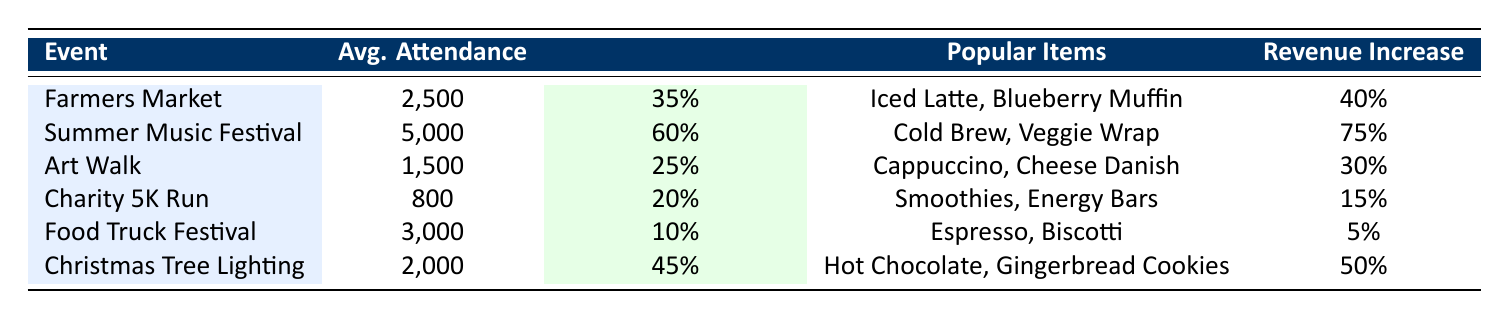What's the average attendance for the Summer Music Festival? The attendance for the Summer Music Festival is listed directly in the table as 5,000, which is a straightforward retrieval from the data.
Answer: 5,000 Which event had the highest revenue increase? By comparing the revenue increases for each event listed in the table, we can see that the Summer Music Festival had the highest at 75%.
Answer: Summer Music Festival Is the Cafe Foot Traffic Increase for the Food Truck Festival greater than for the Christmas Tree Lighting? The Food Truck Festival shows a 10% foot traffic increase, whereas the Christmas Tree Lighting has a 45% increase. Since 10% is less than 45%, the statement is false.
Answer: No How much did cafe foot traffic increase for the Farmers Market compared to the Art Walk? The Farmers Market had a foot traffic increase of 35%, while the Art Walk had a 25% increase. The difference is 35% - 25% = 10%, meaning the Farmers Market had 10% more foot traffic increase than the Art Walk.
Answer: 10% Which popular item was common during events with revenue increases of 50% or more? The only event with a revenue increase of 50% or more is the Christmas Tree Lighting, which mentions popular items including Hot Chocolate and Gingerbread Cookies. These are the items related to the specific revenue increase mentioned. Therefore, both items are related to events with high revenue increase.
Answer: Hot Chocolate, Gingerbread Cookies What is the average cafe foot traffic increase among all events listed? To find the average foot traffic increase, we convert the percentages to decimals, sum them up (0.35 + 0.60 + 0.25 + 0.20 + 0.10 + 0.45 = 1.95), and then divide by the number of events (6): 1.95 / 6 ≈ 0.325 or 32.5%. Therefore, the average cafe foot traffic increase is 32.5%.
Answer: 32.5% Did the Charity 5K Run draw more attendees than the Art Walk? The Charity 5K Run attracted 800 attendees, while the Art Walk had 1,500 attendees. Since 800 is less than 1,500, the statement is false.
Answer: No If we combine the revenue increases of the Farmers Market and Charity 5K Run, what is the total revenue increase? The Farmers Market had a revenue increase of 40%, and the Charity 5K Run had a 15% increase. The total is 40% + 15% = 55%. Thus, combining their revenue increases gives us a total of 55%.
Answer: 55% 